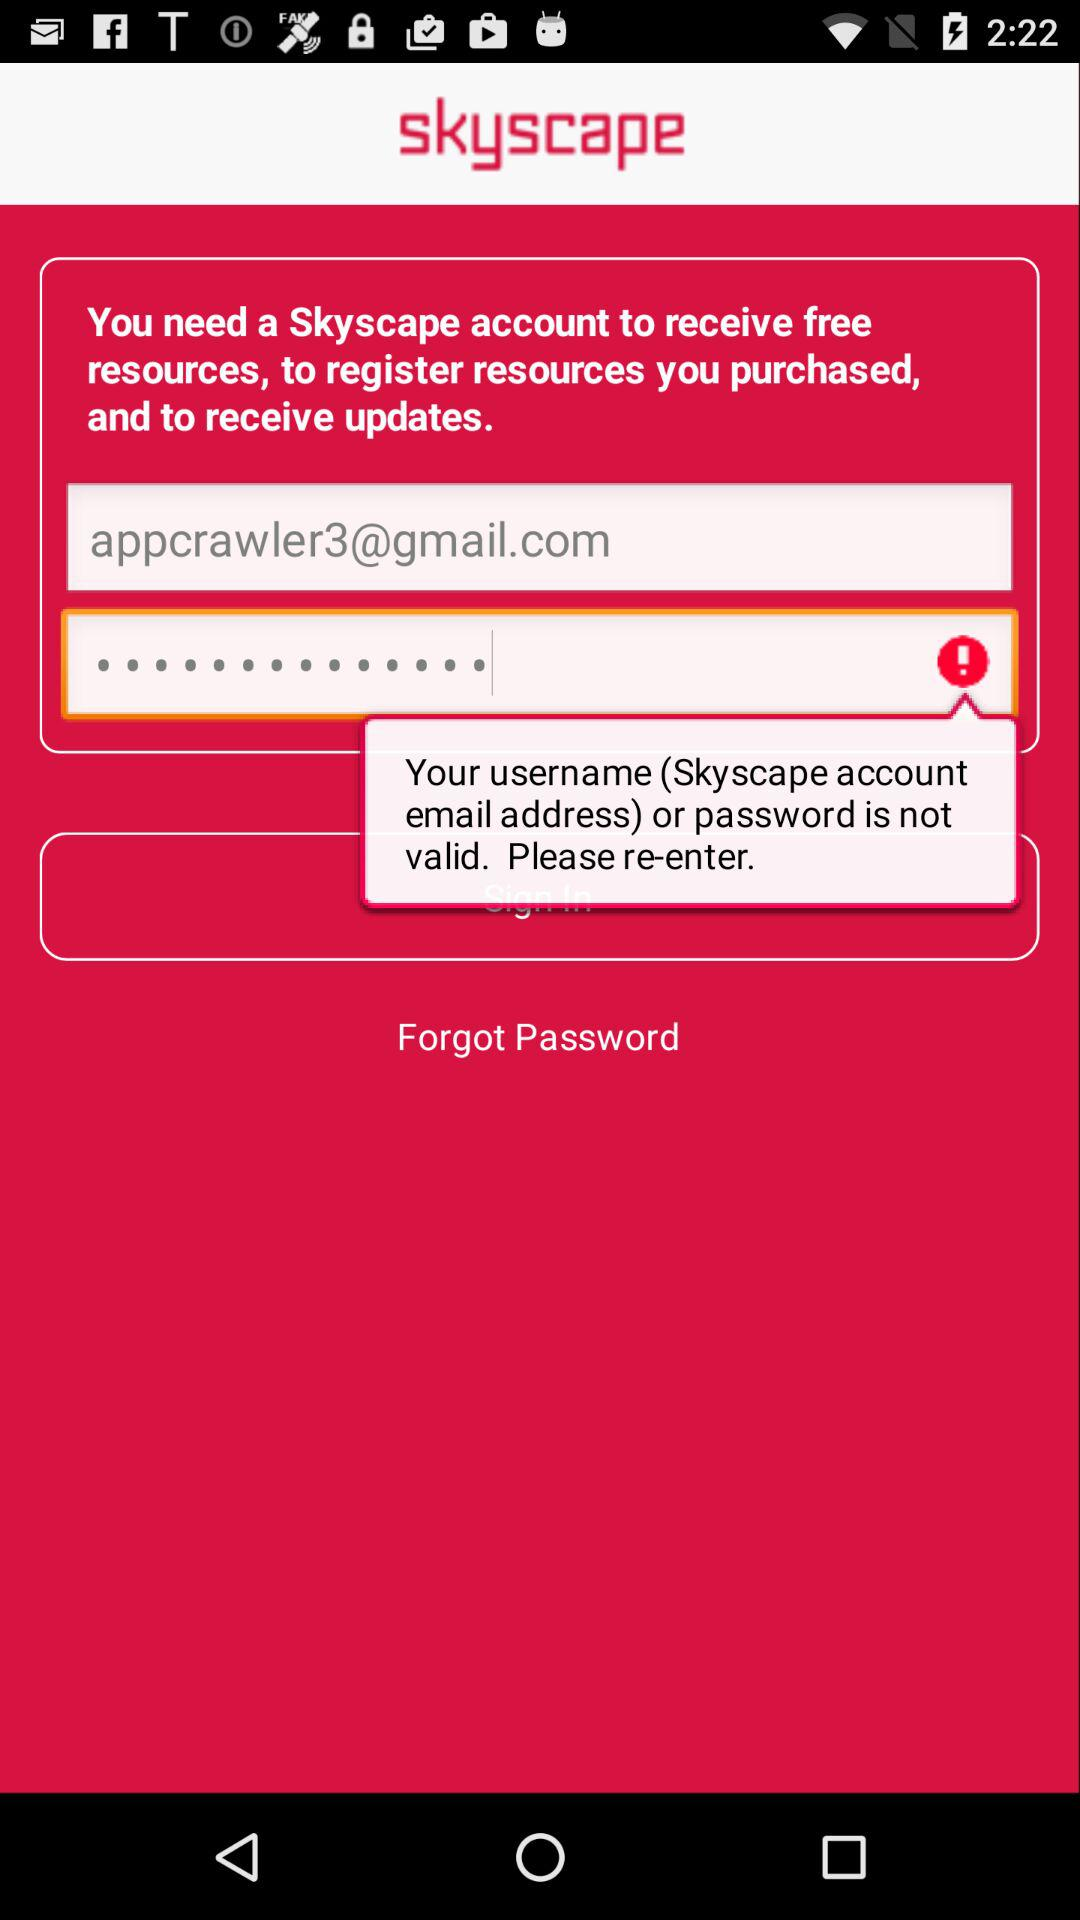How many text inputs have a red exclamation mark next to them?
Answer the question using a single word or phrase. 1 